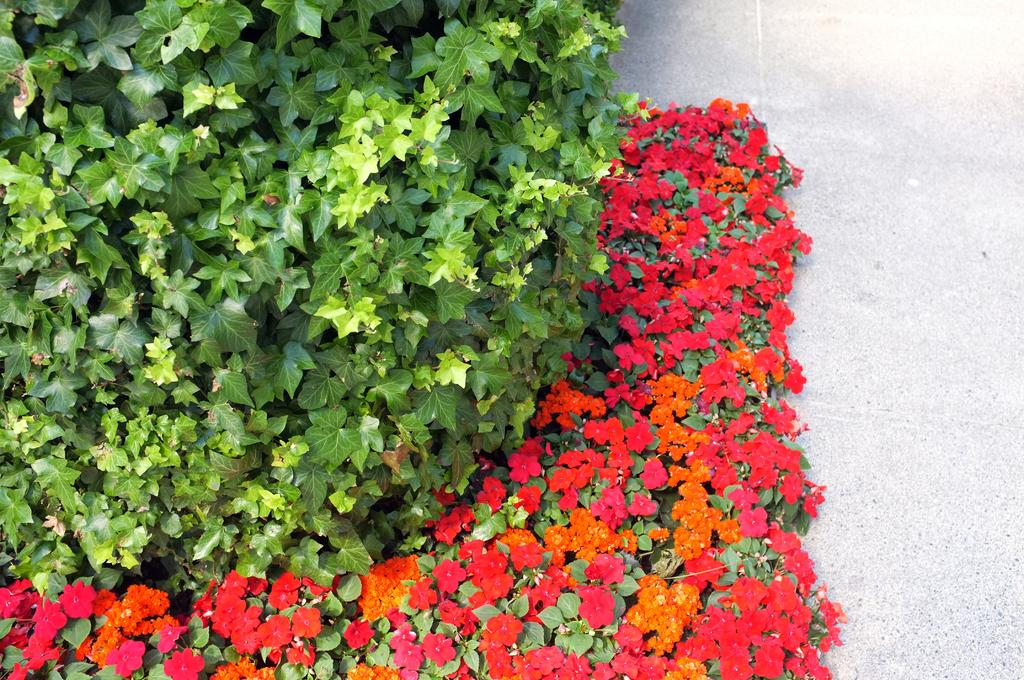What types of living organisms can be seen in the image? Plants and flowers are visible in the image. Where are the plants and flowers located? The plants and flowers are on a surface in the image. How does the steam rise from the plants in the image? There is no steam present in the image; it only features plants and flowers. 